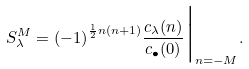<formula> <loc_0><loc_0><loc_500><loc_500>S ^ { M } _ { \lambda } = { ( - 1 ) } ^ { \frac { 1 } { 2 } n ( n + 1 ) } \frac { c _ { \lambda } ( n ) } { c _ { \bullet } ( 0 ) } \Big | _ { n = - M } .</formula> 